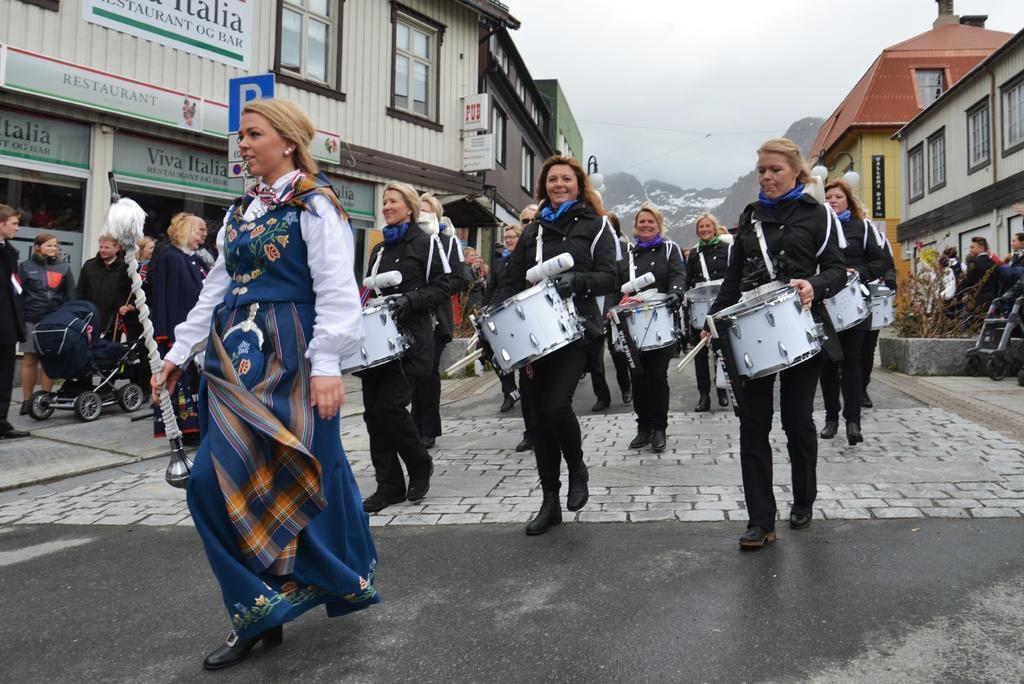Describe this image in one or two sentences. In this image there are group of persons walking in the center and standing on the left side. The woman in the center is walking and holding a stick in her hand and there are persons walking and holding a musical drum. In the background there are mountains and there are buildings. On the left side there are some sign boards and there are banners with some text written on it and the sky is cloudy. 